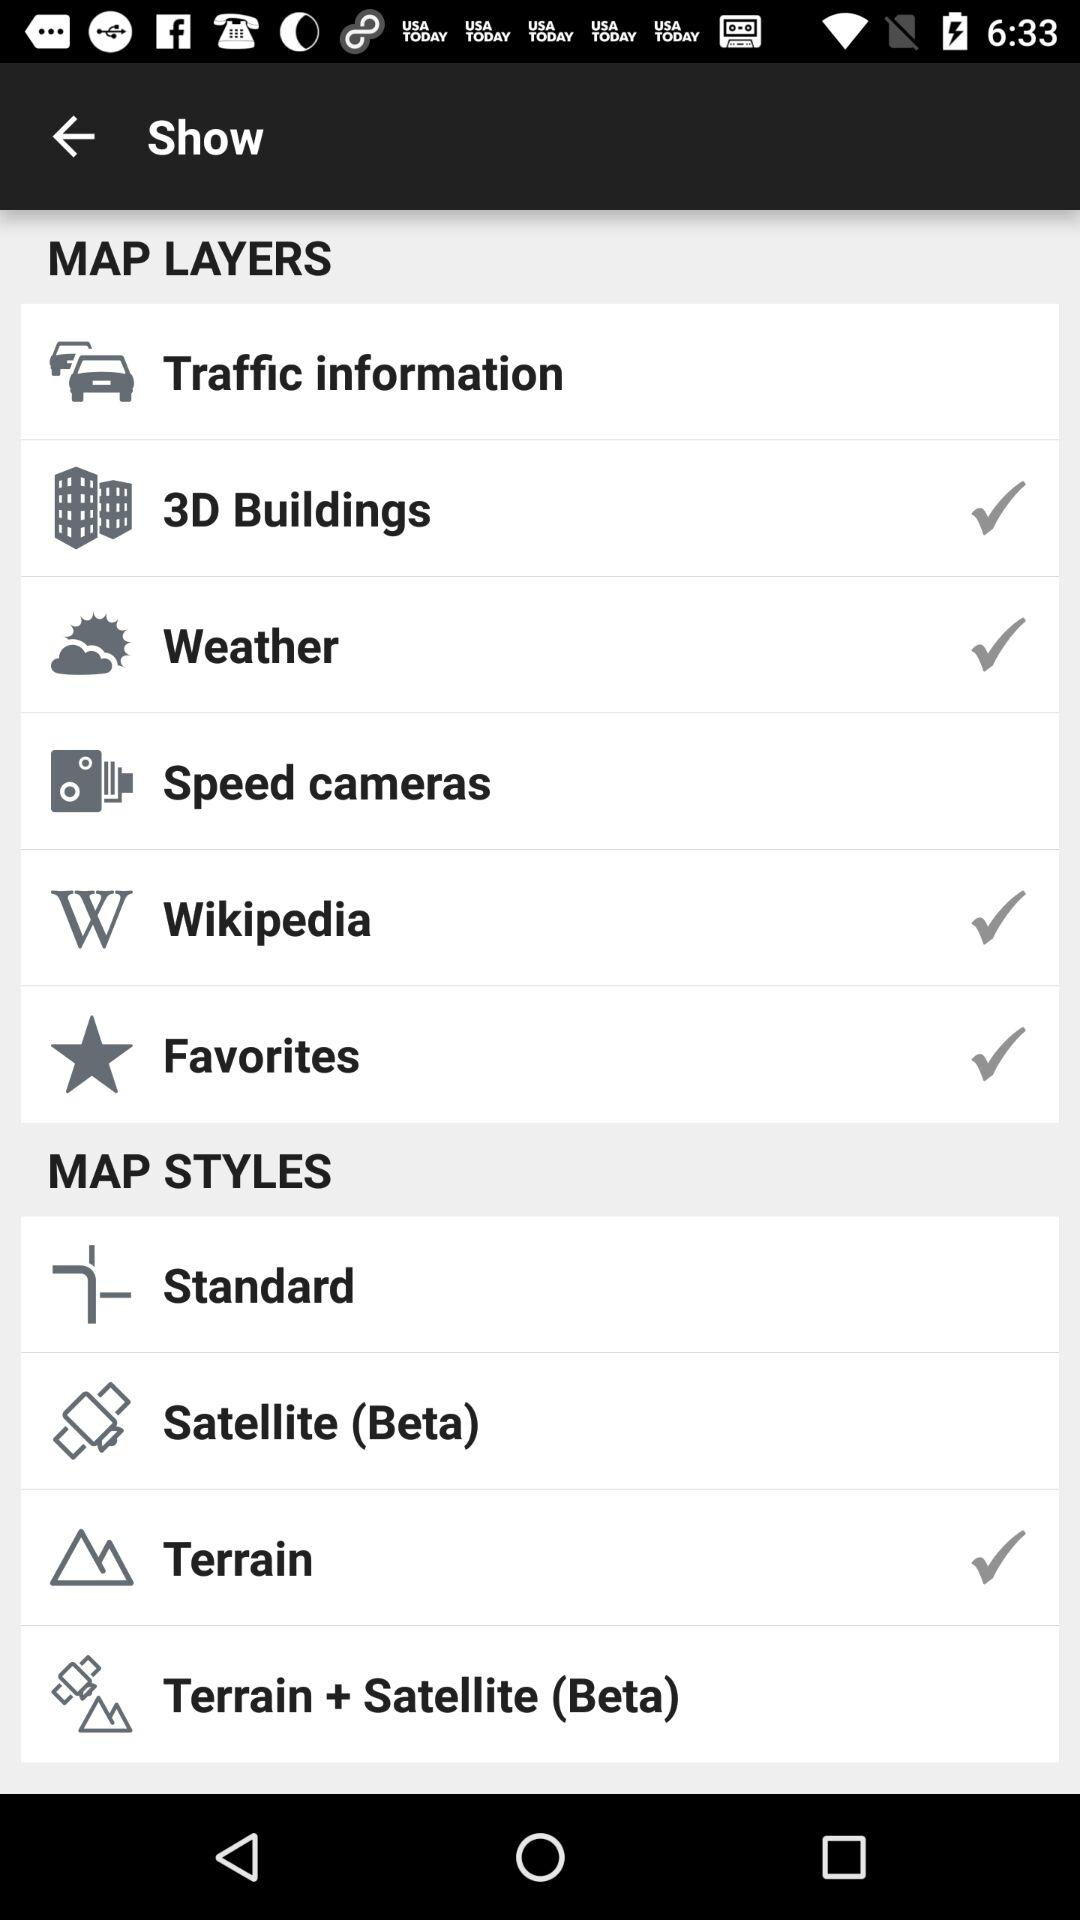How many map layers are available?
Answer the question using a single word or phrase. 6 